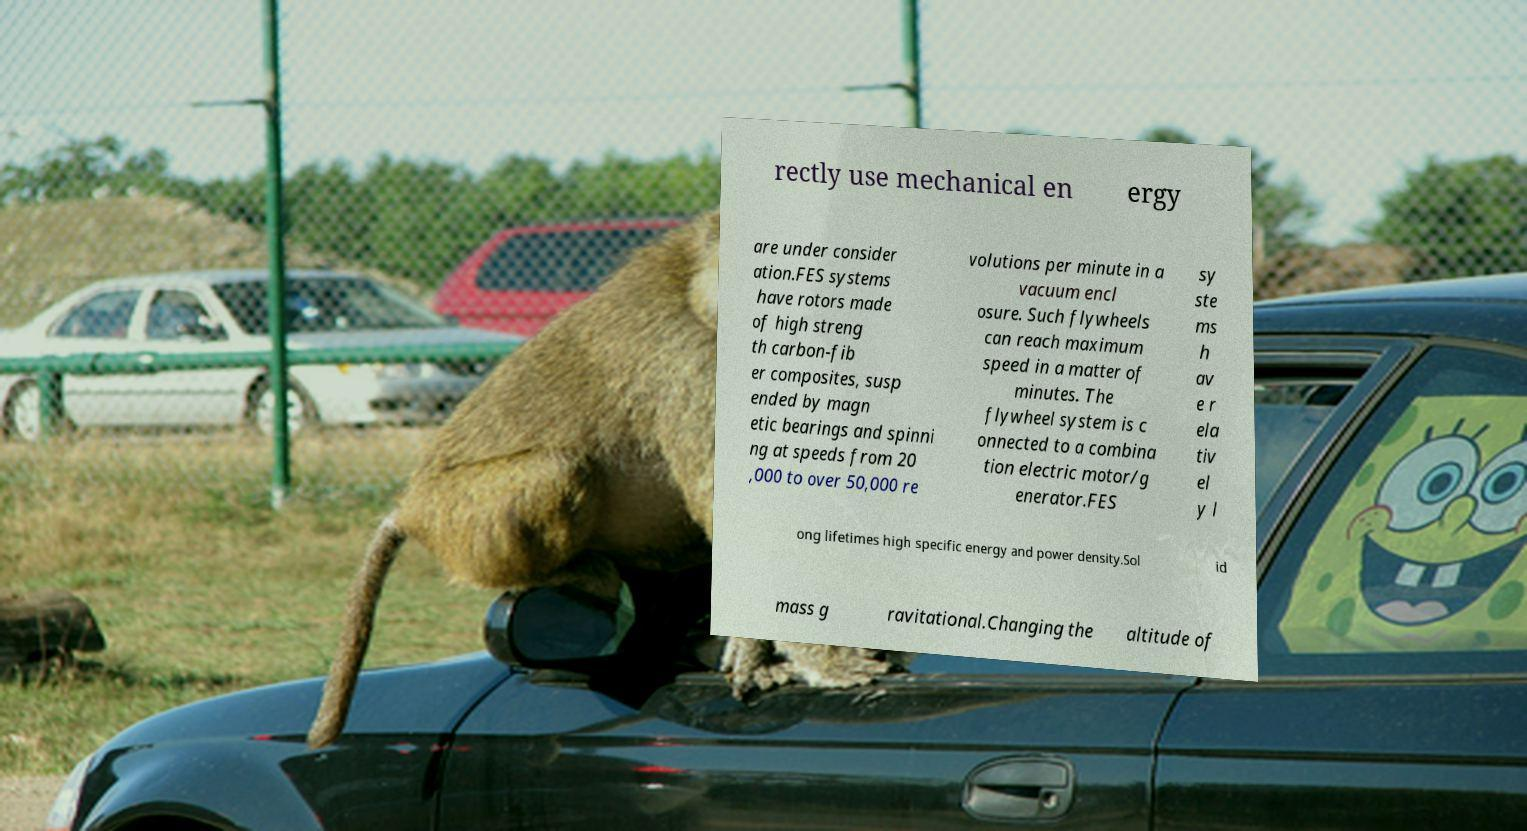There's text embedded in this image that I need extracted. Can you transcribe it verbatim? rectly use mechanical en ergy are under consider ation.FES systems have rotors made of high streng th carbon-fib er composites, susp ended by magn etic bearings and spinni ng at speeds from 20 ,000 to over 50,000 re volutions per minute in a vacuum encl osure. Such flywheels can reach maximum speed in a matter of minutes. The flywheel system is c onnected to a combina tion electric motor/g enerator.FES sy ste ms h av e r ela tiv el y l ong lifetimes high specific energy and power density.Sol id mass g ravitational.Changing the altitude of 